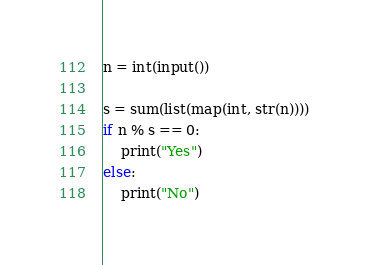Convert code to text. <code><loc_0><loc_0><loc_500><loc_500><_Python_>n = int(input())

s = sum(list(map(int, str(n))))
if n % s == 0:
    print("Yes")
else:
    print("No")
</code> 